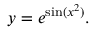<formula> <loc_0><loc_0><loc_500><loc_500>y = e ^ { \sin ( x ^ { 2 } ) } .</formula> 